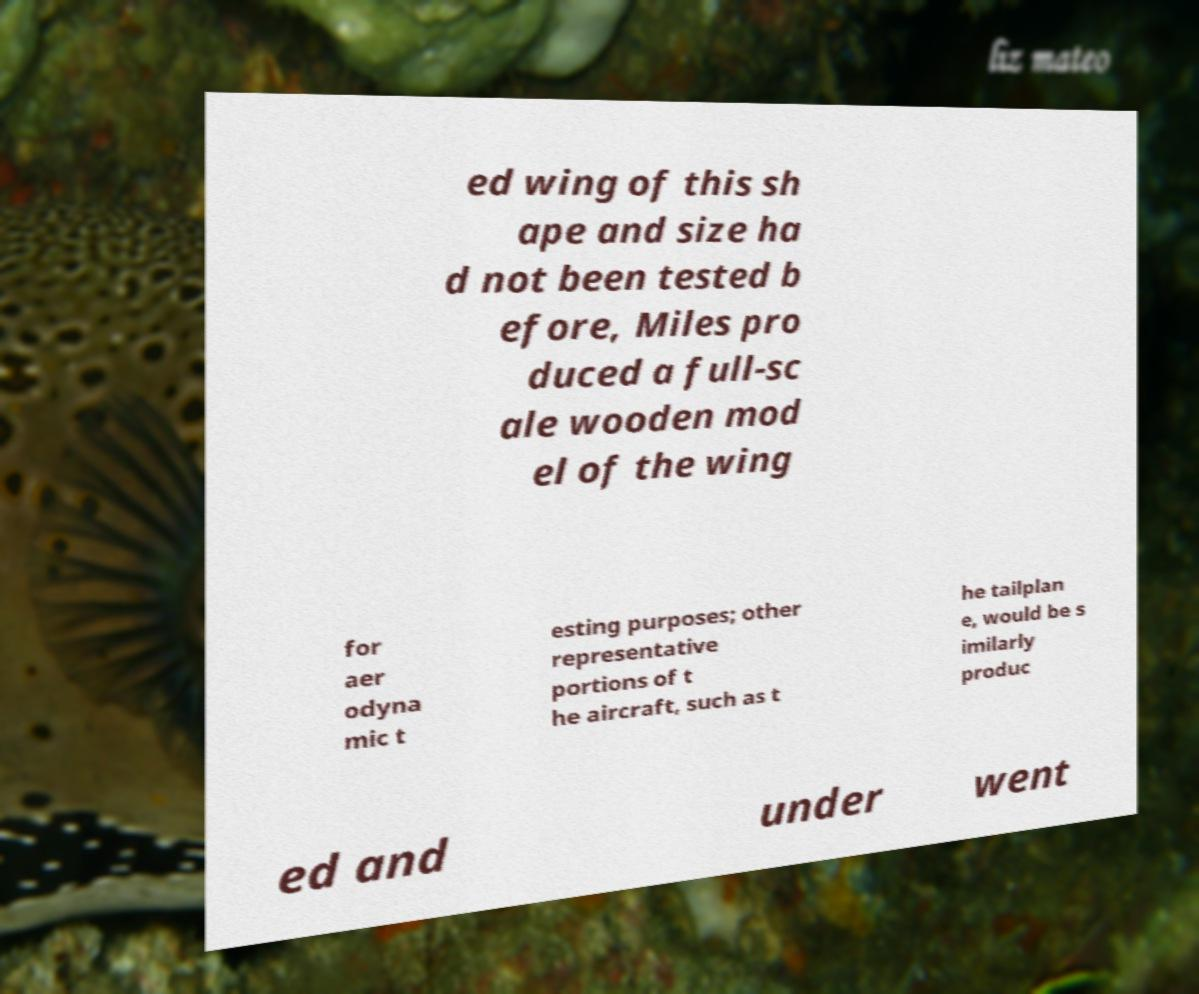I need the written content from this picture converted into text. Can you do that? ed wing of this sh ape and size ha d not been tested b efore, Miles pro duced a full-sc ale wooden mod el of the wing for aer odyna mic t esting purposes; other representative portions of t he aircraft, such as t he tailplan e, would be s imilarly produc ed and under went 